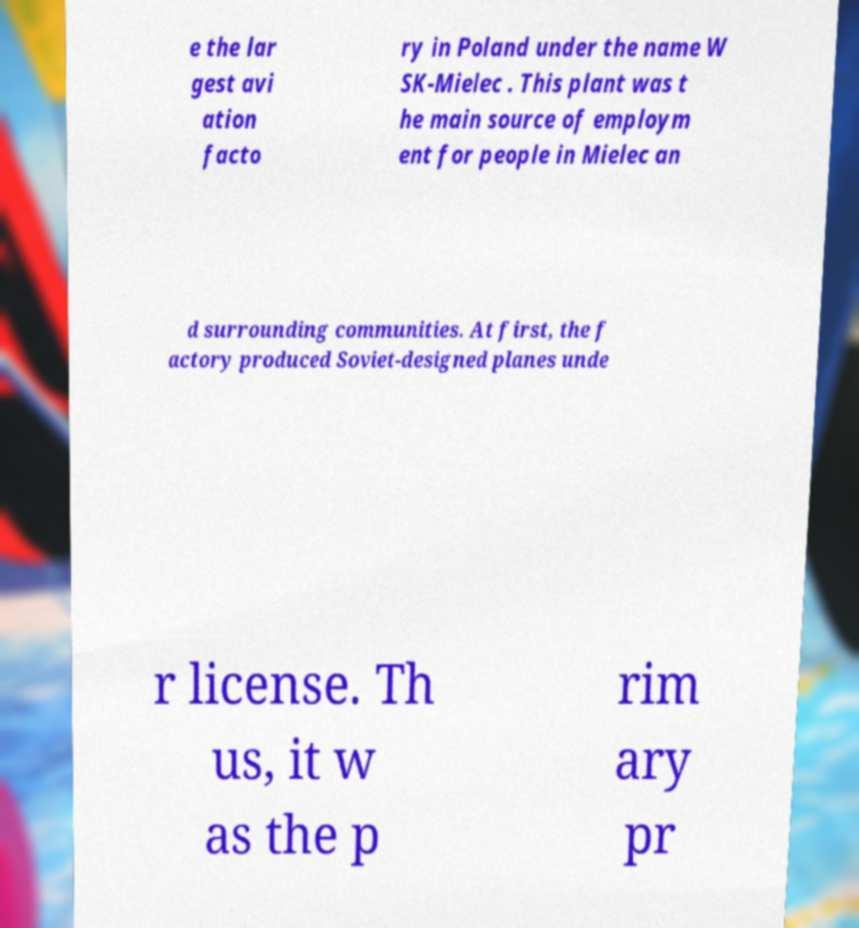Please read and relay the text visible in this image. What does it say? e the lar gest avi ation facto ry in Poland under the name W SK-Mielec . This plant was t he main source of employm ent for people in Mielec an d surrounding communities. At first, the f actory produced Soviet-designed planes unde r license. Th us, it w as the p rim ary pr 